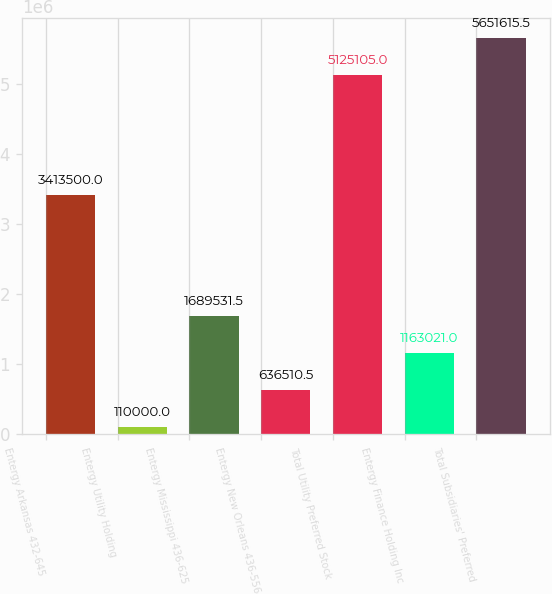<chart> <loc_0><loc_0><loc_500><loc_500><bar_chart><fcel>Entergy Arkansas 432-645<fcel>Entergy Utility Holding<fcel>Entergy Mississippi 436-625<fcel>Entergy New Orleans 436-556<fcel>Total Utility Preferred Stock<fcel>Entergy Finance Holding Inc<fcel>Total Subsidiaries' Preferred<nl><fcel>3.4135e+06<fcel>110000<fcel>1.68953e+06<fcel>636510<fcel>5.1251e+06<fcel>1.16302e+06<fcel>5.65162e+06<nl></chart> 